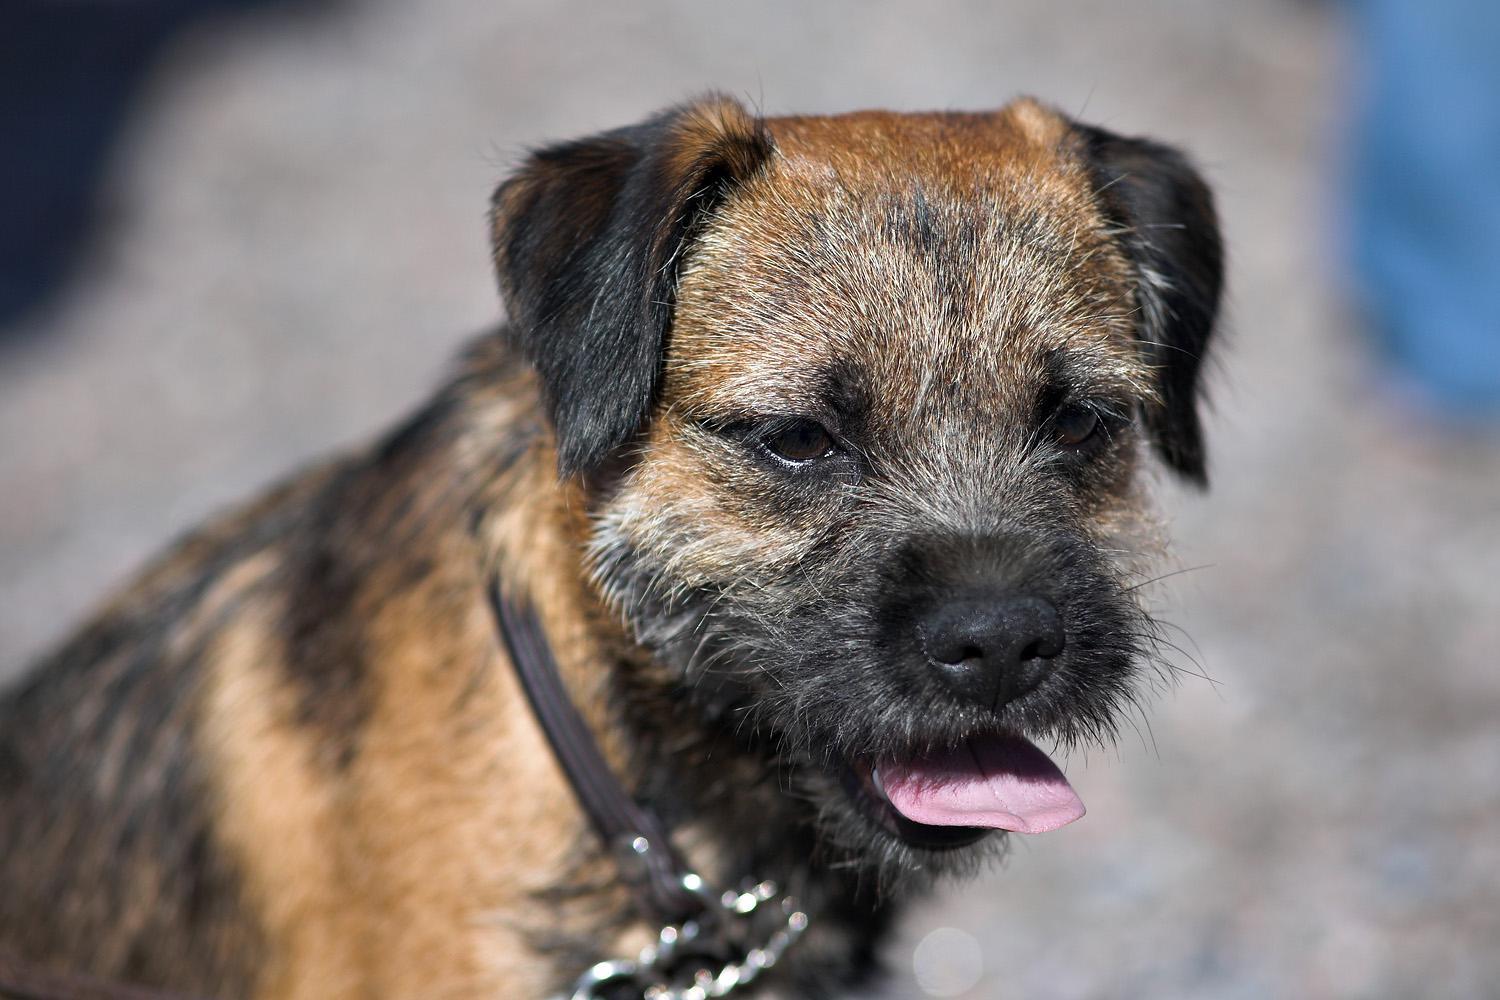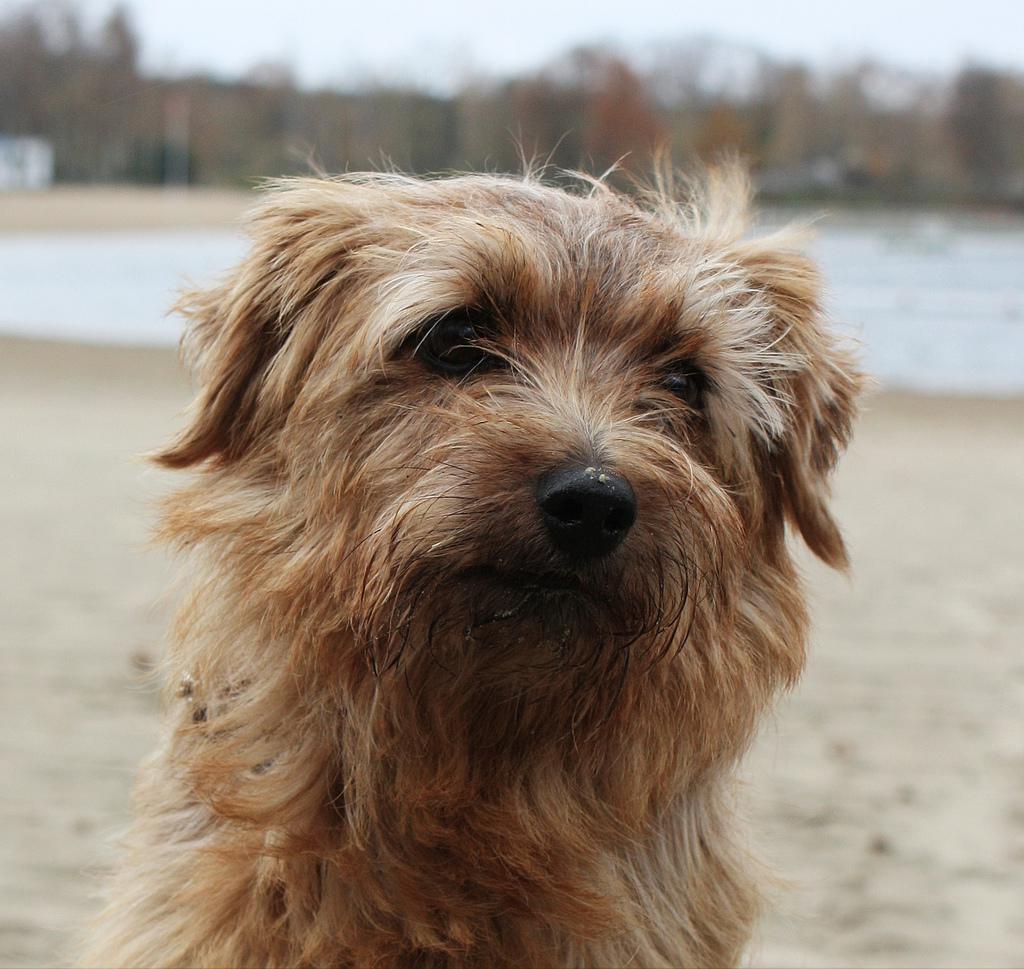The first image is the image on the left, the second image is the image on the right. Analyze the images presented: Is the assertion "A collar is visible around the neck of the dog in the right image." valid? Answer yes or no. No. 